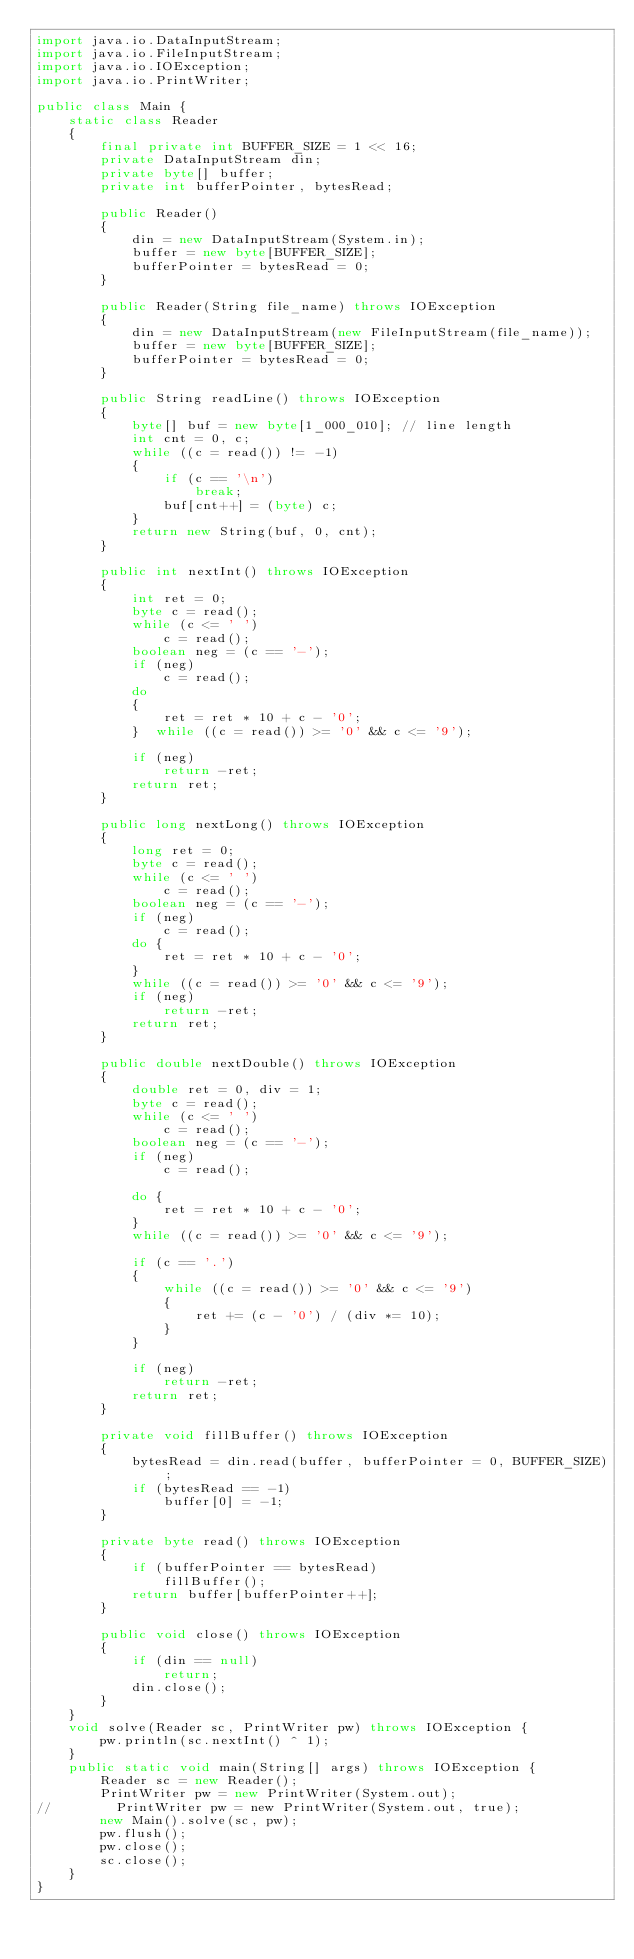Convert code to text. <code><loc_0><loc_0><loc_500><loc_500><_Java_>import java.io.DataInputStream;
import java.io.FileInputStream;
import java.io.IOException;
import java.io.PrintWriter;

public class Main {
    static class Reader
    {
        final private int BUFFER_SIZE = 1 << 16;
        private DataInputStream din;
        private byte[] buffer;
        private int bufferPointer, bytesRead;

        public Reader()
        {
            din = new DataInputStream(System.in);
            buffer = new byte[BUFFER_SIZE];
            bufferPointer = bytesRead = 0;
        }

        public Reader(String file_name) throws IOException
        {
            din = new DataInputStream(new FileInputStream(file_name));
            buffer = new byte[BUFFER_SIZE];
            bufferPointer = bytesRead = 0;
        }

        public String readLine() throws IOException
        {
            byte[] buf = new byte[1_000_010]; // line length
            int cnt = 0, c;
            while ((c = read()) != -1)
            {
                if (c == '\n')
                    break;
                buf[cnt++] = (byte) c;
            }
            return new String(buf, 0, cnt);
        }

        public int nextInt() throws IOException
        {
            int ret = 0;
            byte c = read();
            while (c <= ' ')
                c = read();
            boolean neg = (c == '-');
            if (neg)
                c = read();
            do
            {
                ret = ret * 10 + c - '0';
            }  while ((c = read()) >= '0' && c <= '9');

            if (neg)
                return -ret;
            return ret;
        }

        public long nextLong() throws IOException
        {
            long ret = 0;
            byte c = read();
            while (c <= ' ')
                c = read();
            boolean neg = (c == '-');
            if (neg)
                c = read();
            do {
                ret = ret * 10 + c - '0';
            }
            while ((c = read()) >= '0' && c <= '9');
            if (neg)
                return -ret;
            return ret;
        }

        public double nextDouble() throws IOException
        {
            double ret = 0, div = 1;
            byte c = read();
            while (c <= ' ')
                c = read();
            boolean neg = (c == '-');
            if (neg)
                c = read();

            do {
                ret = ret * 10 + c - '0';
            }
            while ((c = read()) >= '0' && c <= '9');

            if (c == '.')
            {
                while ((c = read()) >= '0' && c <= '9')
                {
                    ret += (c - '0') / (div *= 10);
                }
            }

            if (neg)
                return -ret;
            return ret;
        }

        private void fillBuffer() throws IOException
        {
            bytesRead = din.read(buffer, bufferPointer = 0, BUFFER_SIZE);
            if (bytesRead == -1)
                buffer[0] = -1;
        }

        private byte read() throws IOException
        {
            if (bufferPointer == bytesRead)
                fillBuffer();
            return buffer[bufferPointer++];
        }

        public void close() throws IOException
        {
            if (din == null)
                return;
            din.close();
        }
    }
    void solve(Reader sc, PrintWriter pw) throws IOException {
        pw.println(sc.nextInt() ^ 1);
    }
    public static void main(String[] args) throws IOException {
        Reader sc = new Reader();
        PrintWriter pw = new PrintWriter(System.out);
//        PrintWriter pw = new PrintWriter(System.out, true);
        new Main().solve(sc, pw);
        pw.flush();
        pw.close();
        sc.close();
    }
}


</code> 